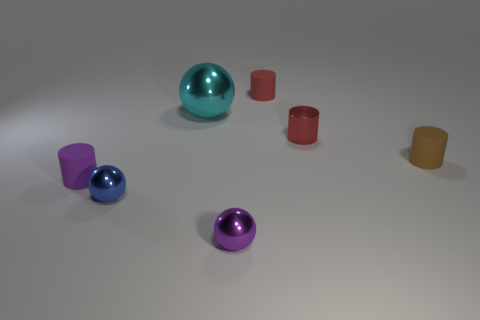There is a small metal object that is left of the small purple metallic thing; what shape is it? The small metal object to the left of the small purple one is a cylinder. Its surface reflects the soft lighting in the room, which emphasizes its circular cylindrical shape. 